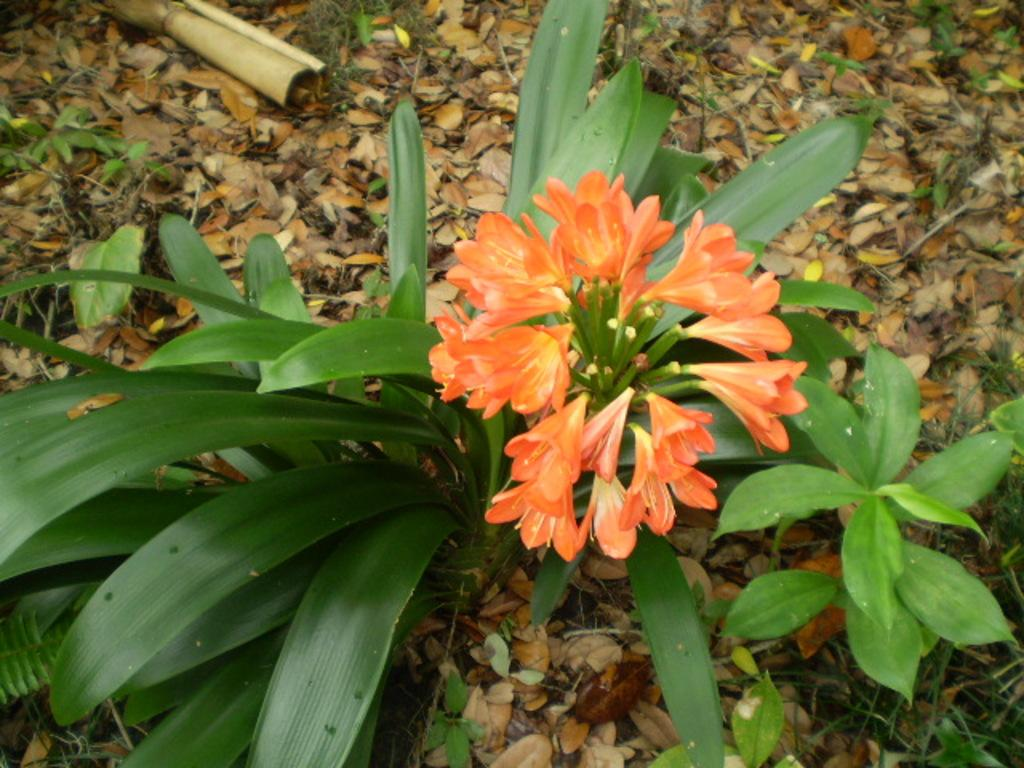What type of vegetation is present on the ground in the image? There are plants on the ground in the image. Can you describe the flowers on the plants in the image? There are flowers on a plant in the image. What is the condition of the leaves around the plants in the image? There are dried leaves around the plants in the image. Are there any small plants visible on the ground in the image? Yes, there are small plants on the ground in the image. What type of lettuce can be seen growing in the image? There is no lettuce present in the image; it features plants with flowers and dried leaves. How many clocks are visible in the image? There are no clocks present in the image. 